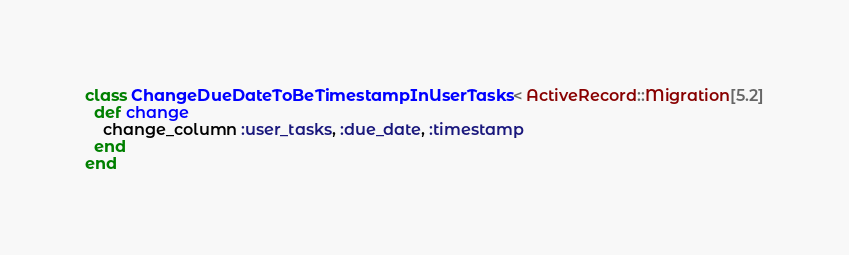<code> <loc_0><loc_0><loc_500><loc_500><_Ruby_>class ChangeDueDateToBeTimestampInUserTasks < ActiveRecord::Migration[5.2]
  def change
    change_column :user_tasks, :due_date, :timestamp
  end
end
</code> 